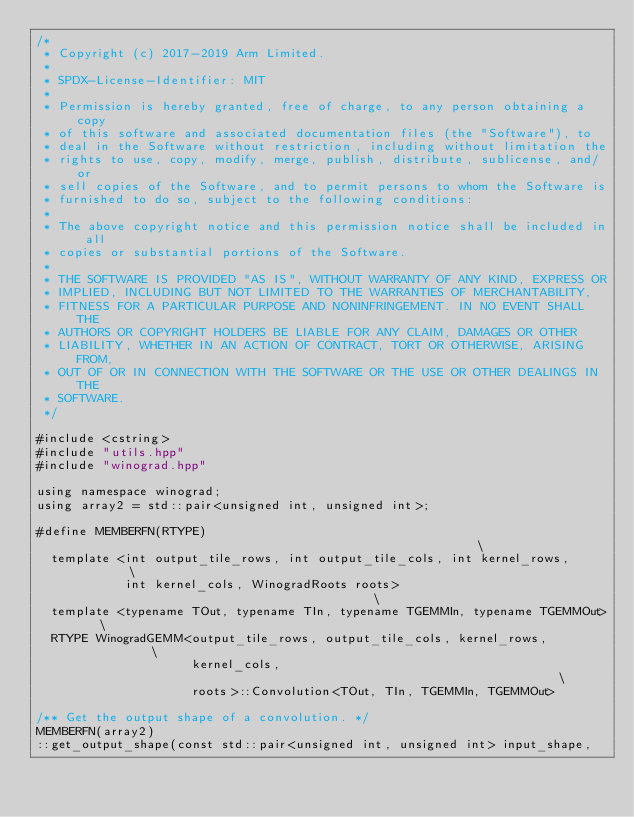Convert code to text. <code><loc_0><loc_0><loc_500><loc_500><_C++_>/*
 * Copyright (c) 2017-2019 Arm Limited.
 *
 * SPDX-License-Identifier: MIT
 *
 * Permission is hereby granted, free of charge, to any person obtaining a copy
 * of this software and associated documentation files (the "Software"), to
 * deal in the Software without restriction, including without limitation the
 * rights to use, copy, modify, merge, publish, distribute, sublicense, and/or
 * sell copies of the Software, and to permit persons to whom the Software is
 * furnished to do so, subject to the following conditions:
 *
 * The above copyright notice and this permission notice shall be included in all
 * copies or substantial portions of the Software.
 *
 * THE SOFTWARE IS PROVIDED "AS IS", WITHOUT WARRANTY OF ANY KIND, EXPRESS OR
 * IMPLIED, INCLUDING BUT NOT LIMITED TO THE WARRANTIES OF MERCHANTABILITY,
 * FITNESS FOR A PARTICULAR PURPOSE AND NONINFRINGEMENT. IN NO EVENT SHALL THE
 * AUTHORS OR COPYRIGHT HOLDERS BE LIABLE FOR ANY CLAIM, DAMAGES OR OTHER
 * LIABILITY, WHETHER IN AN ACTION OF CONTRACT, TORT OR OTHERWISE, ARISING FROM,
 * OUT OF OR IN CONNECTION WITH THE SOFTWARE OR THE USE OR OTHER DEALINGS IN THE
 * SOFTWARE.
 */

#include <cstring>
#include "utils.hpp"
#include "winograd.hpp"

using namespace winograd;
using array2 = std::pair<unsigned int, unsigned int>;

#define MEMBERFN(RTYPE)                                                        \
  template <int output_tile_rows, int output_tile_cols, int kernel_rows,       \
            int kernel_cols, WinogradRoots roots>                              \
  template <typename TOut, typename TIn, typename TGEMMIn, typename TGEMMOut>  \
  RTYPE WinogradGEMM<output_tile_rows, output_tile_cols, kernel_rows,          \
                     kernel_cols,                                              \
                     roots>::Convolution<TOut, TIn, TGEMMIn, TGEMMOut>

/** Get the output shape of a convolution. */
MEMBERFN(array2)
::get_output_shape(const std::pair<unsigned int, unsigned int> input_shape,</code> 